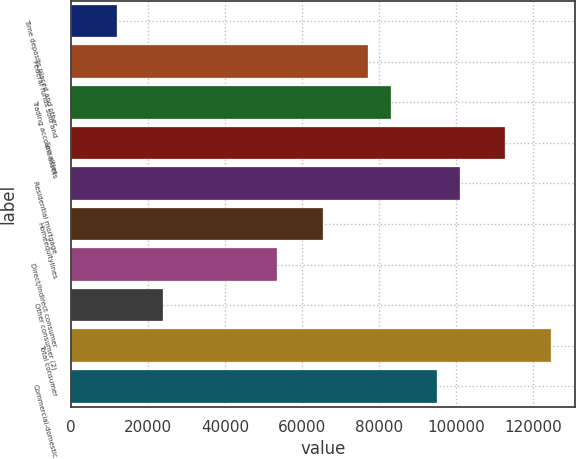Convert chart to OTSL. <chart><loc_0><loc_0><loc_500><loc_500><bar_chart><fcel>Time deposits placed and other<fcel>Federal funds sold and<fcel>Trading account assets<fcel>Securities<fcel>Residential mortgage<fcel>Homeequitylines<fcel>Direct/Indirect consumer<fcel>Other consumer (2)<fcel>Total consumer<fcel>Commercial-domestic<nl><fcel>12082<fcel>77224<fcel>83146<fcel>112756<fcel>100912<fcel>65380<fcel>53536<fcel>23926<fcel>124600<fcel>94990<nl></chart> 